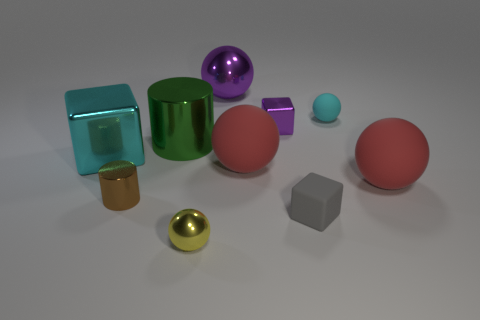Subtract all tiny shiny balls. How many balls are left? 4 Subtract all brown cubes. How many red spheres are left? 2 Subtract all gray cubes. How many cubes are left? 2 Subtract all blocks. How many objects are left? 7 Subtract 1 spheres. How many spheres are left? 4 Add 5 tiny yellow things. How many tiny yellow things are left? 6 Add 1 brown shiny cylinders. How many brown shiny cylinders exist? 2 Subtract 1 cyan spheres. How many objects are left? 9 Subtract all brown spheres. Subtract all cyan cylinders. How many spheres are left? 5 Subtract all small brown rubber blocks. Subtract all big purple metallic objects. How many objects are left? 9 